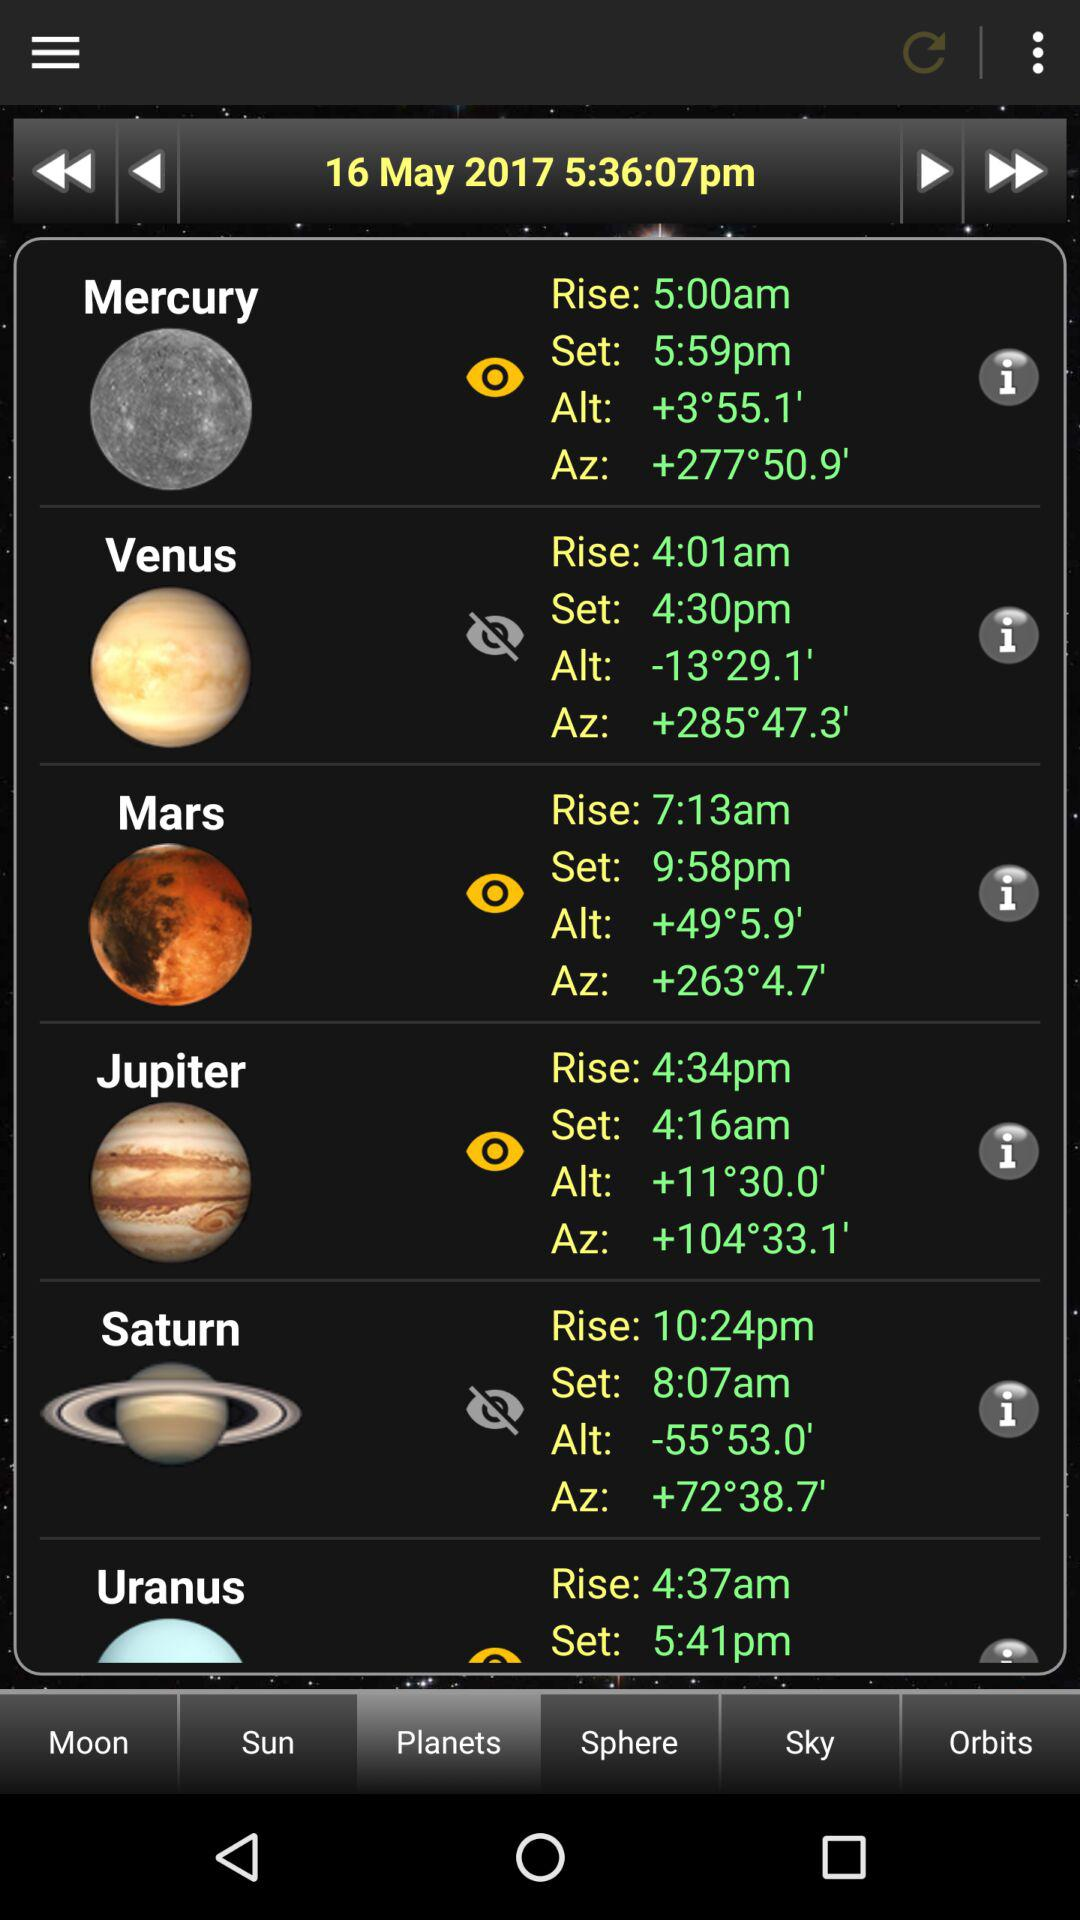What is Saturn's set time? The Saturn's set time is 8:07 am. 